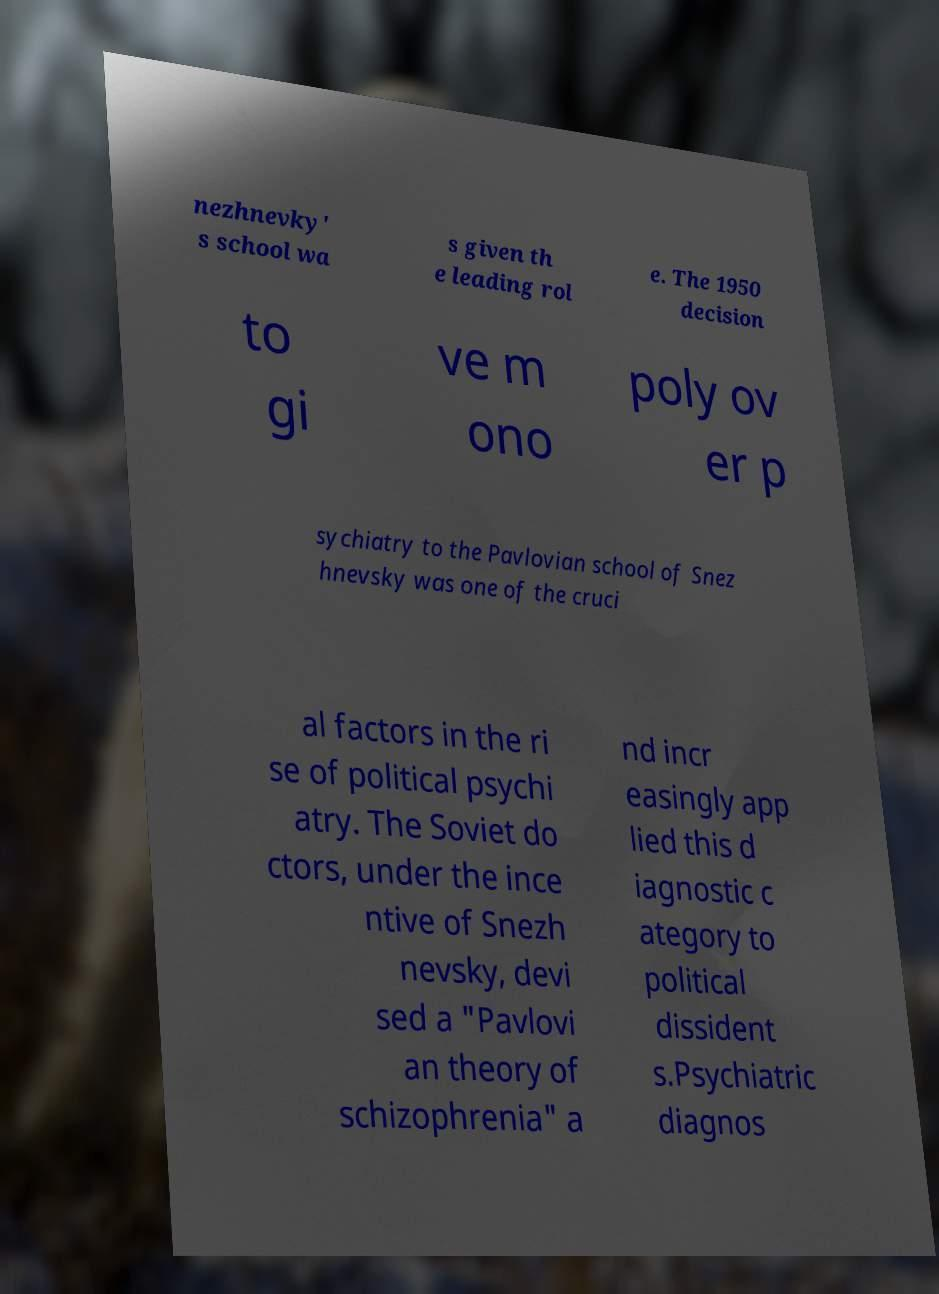Can you read and provide the text displayed in the image?This photo seems to have some interesting text. Can you extract and type it out for me? nezhnevky' s school wa s given th e leading rol e. The 1950 decision to gi ve m ono poly ov er p sychiatry to the Pavlovian school of Snez hnevsky was one of the cruci al factors in the ri se of political psychi atry. The Soviet do ctors, under the ince ntive of Snezh nevsky, devi sed a "Pavlovi an theory of schizophrenia" a nd incr easingly app lied this d iagnostic c ategory to political dissident s.Psychiatric diagnos 